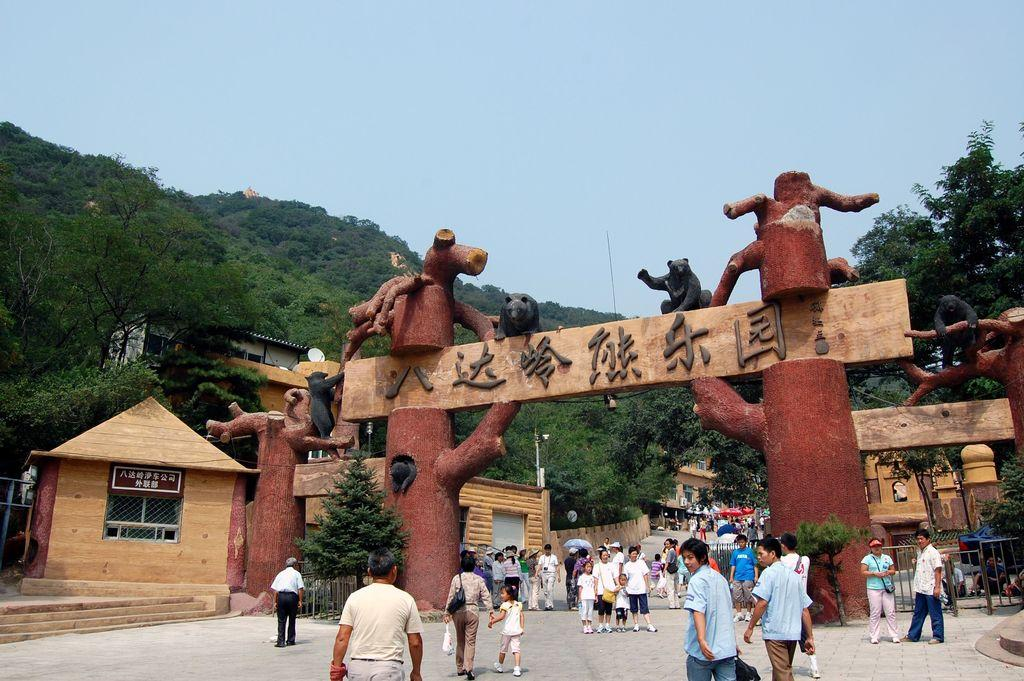How many people are in the image? There is a group of people in the image, but the exact number is not specified. What are the people in the image doing? Some people are standing, while others are walking. What can be seen in the background of the image? There is an arch, houses, and trees in the background of the image. What type of map can be seen on the ground in the image? There is no map present in the image; it features a group of people with some standing and others walking, along with an arch, houses, and trees in the background. 